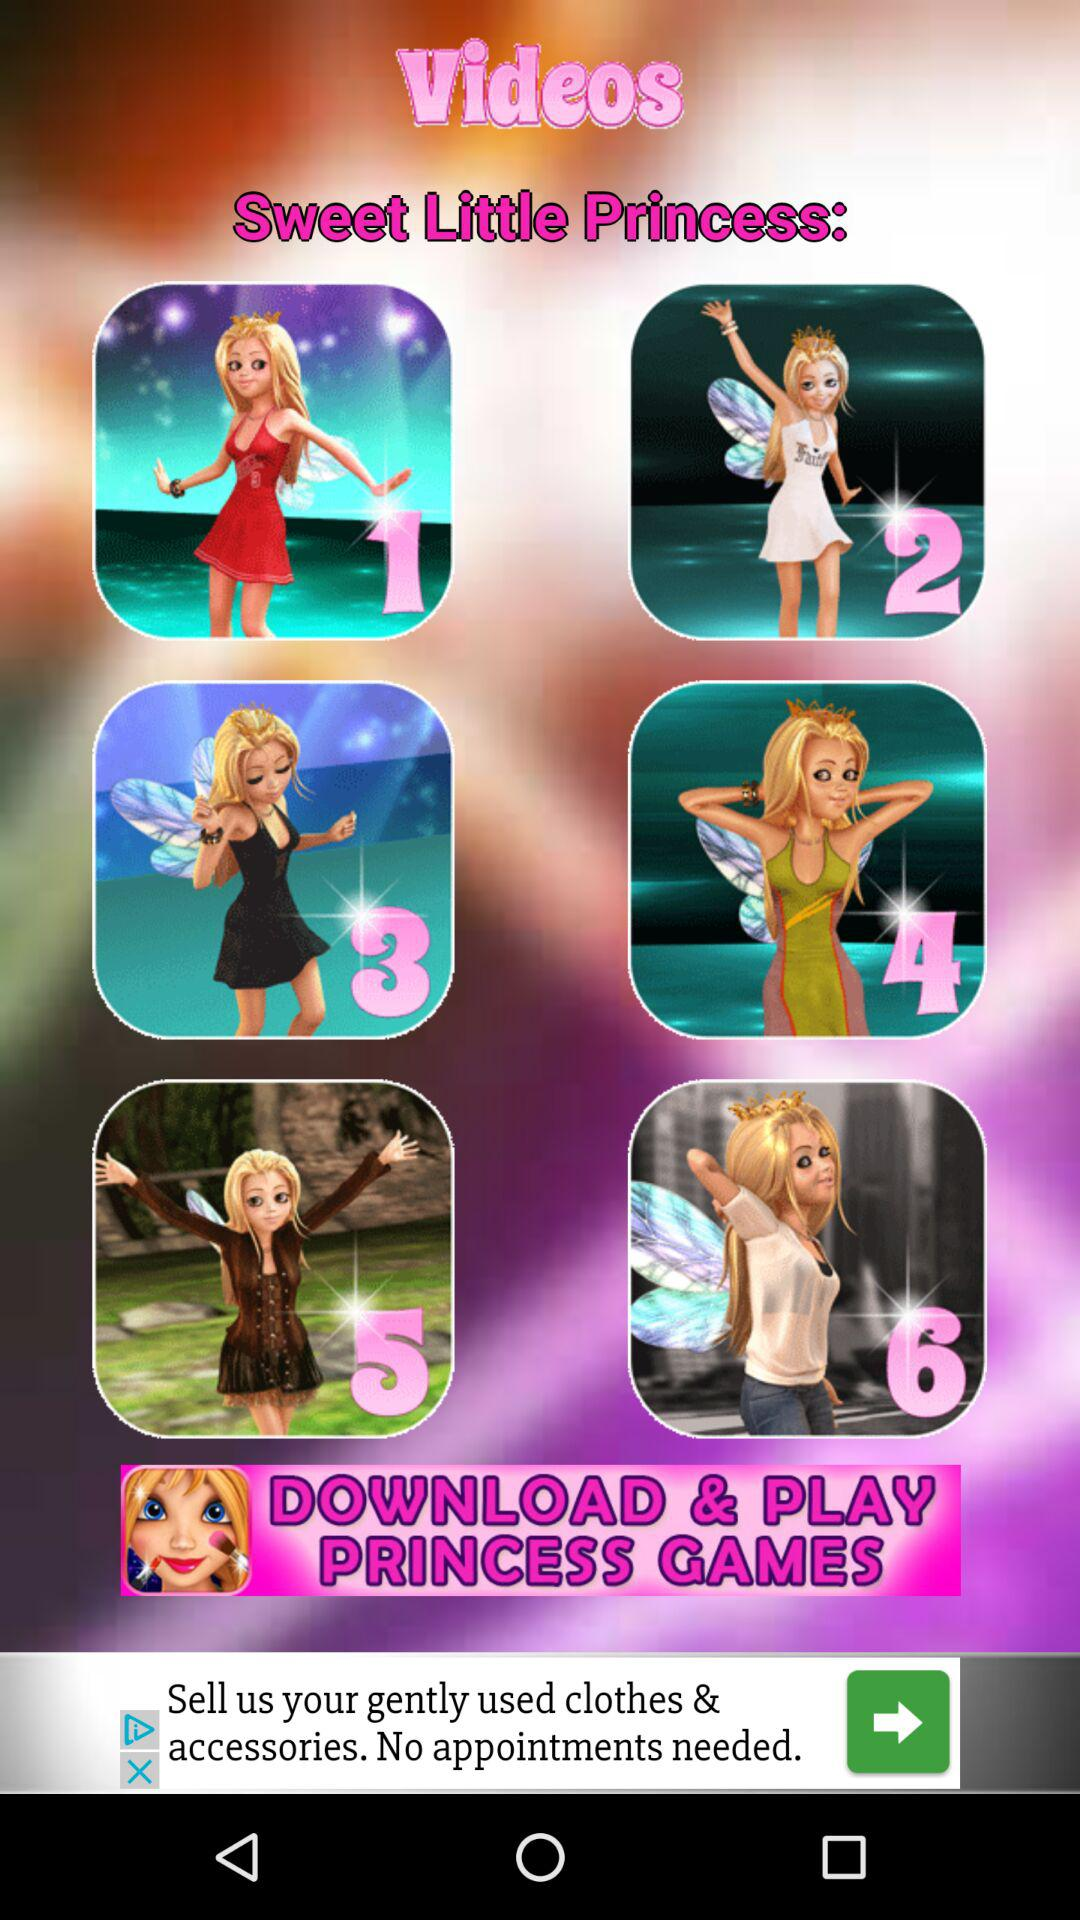What is the name of the application? The name of the application is "PRINCESS GAMES". 